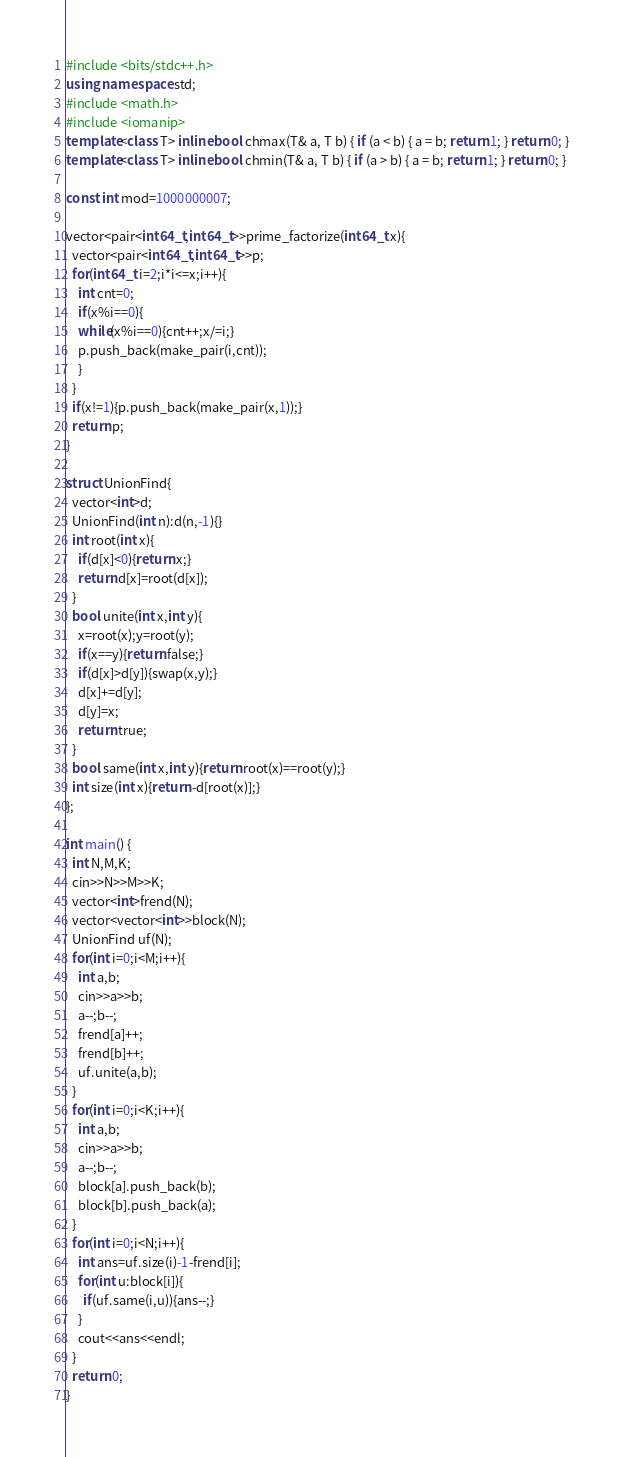Convert code to text. <code><loc_0><loc_0><loc_500><loc_500><_C++_>#include <bits/stdc++.h>
using namespace std;
#include <math.h>
#include <iomanip>
template<class T> inline bool chmax(T& a, T b) { if (a < b) { a = b; return 1; } return 0; }
template<class T> inline bool chmin(T& a, T b) { if (a > b) { a = b; return 1; } return 0; }

const int mod=1000000007;

vector<pair<int64_t,int64_t>>prime_factorize(int64_t x){
  vector<pair<int64_t,int64_t>>p;
  for(int64_t i=2;i*i<=x;i++){
    int cnt=0;
    if(x%i==0){
    while(x%i==0){cnt++;x/=i;}
    p.push_back(make_pair(i,cnt));
    }
  }
  if(x!=1){p.push_back(make_pair(x,1));}
  return p; 
}

struct UnionFind{
  vector<int>d;
  UnionFind(int n):d(n,-1){}
  int root(int x){
    if(d[x]<0){return x;}
    return d[x]=root(d[x]);
  }
  bool unite(int x,int y){
    x=root(x);y=root(y);
    if(x==y){return false;}
    if(d[x]>d[y]){swap(x,y);}
    d[x]+=d[y];
    d[y]=x;
    return true;
  }
  bool same(int x,int y){return root(x)==root(y);}
  int size(int x){return -d[root(x)];}
};

int main() {
  int N,M,K;
  cin>>N>>M>>K;
  vector<int>frend(N);
  vector<vector<int>>block(N);
  UnionFind uf(N);
  for(int i=0;i<M;i++){
    int a,b;
    cin>>a>>b;
    a--;b--;
    frend[a]++;
    frend[b]++;
    uf.unite(a,b);
  } 
  for(int i=0;i<K;i++){
    int a,b;
    cin>>a>>b;
    a--;b--;
    block[a].push_back(b);
    block[b].push_back(a);
  }
  for(int i=0;i<N;i++){
    int ans=uf.size(i)-1-frend[i];
    for(int u:block[i]){
      if(uf.same(i,u)){ans--;}
    }
    cout<<ans<<endl;
  }
  return 0;
}</code> 